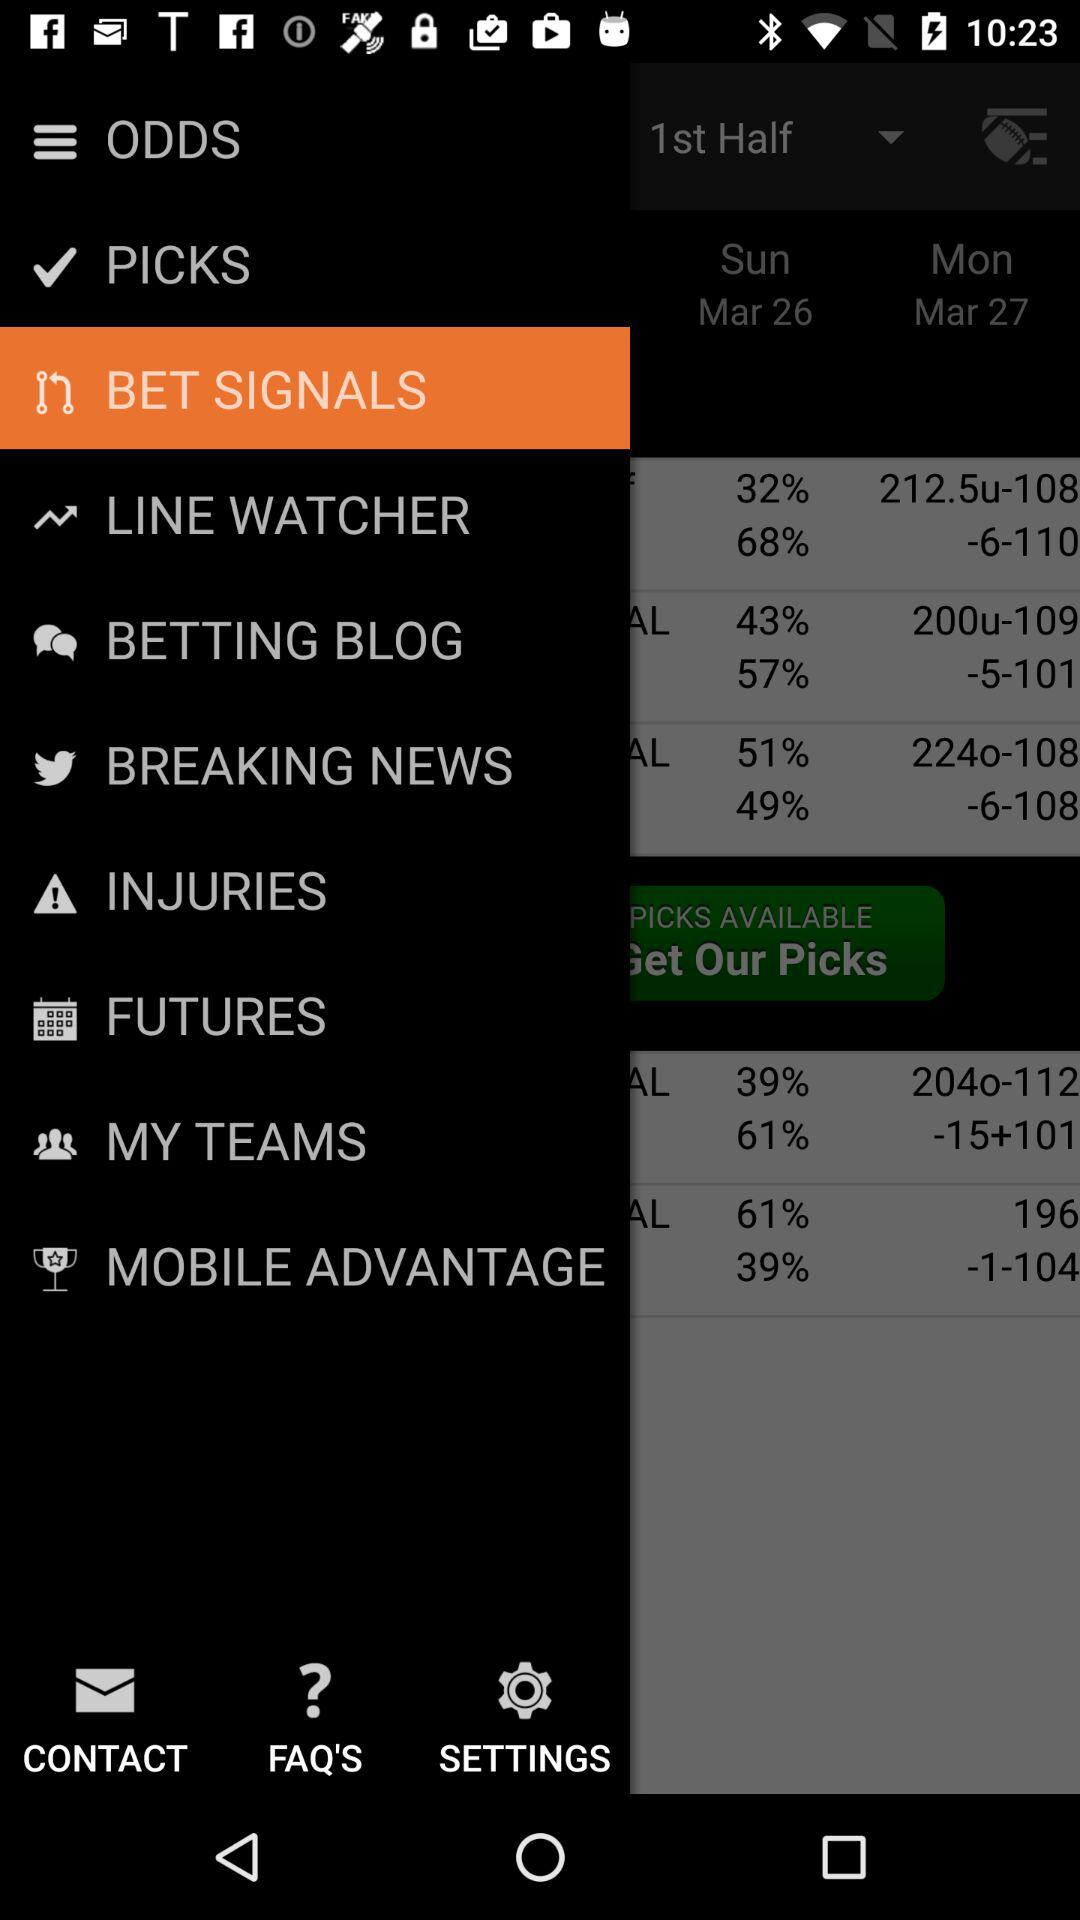What is the date on Sunday? The date is March 26. 